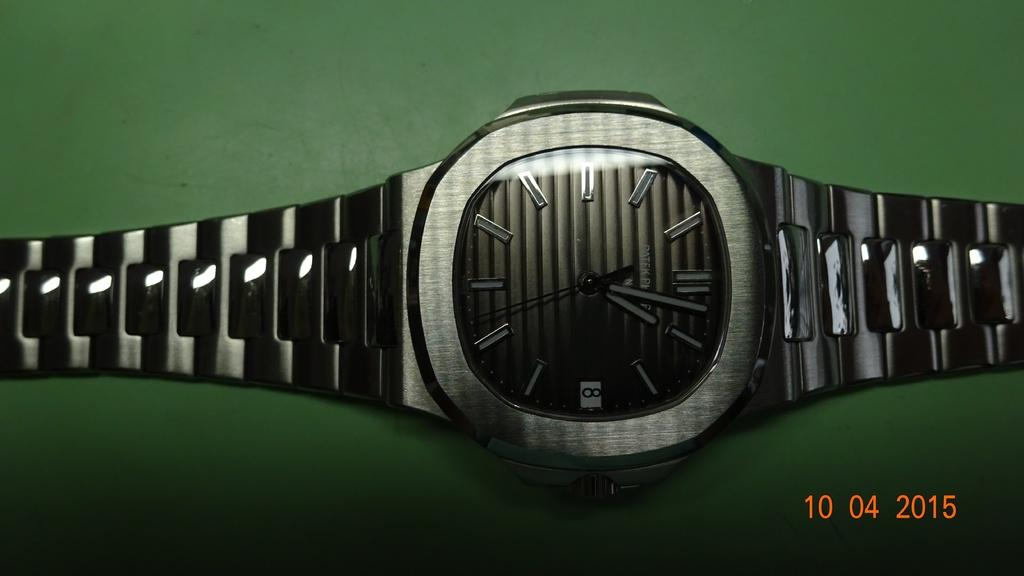<image>
Share a concise interpretation of the image provided. A picture of a silver watch with grayish black face with the tine 1:02 laying on a green background. 